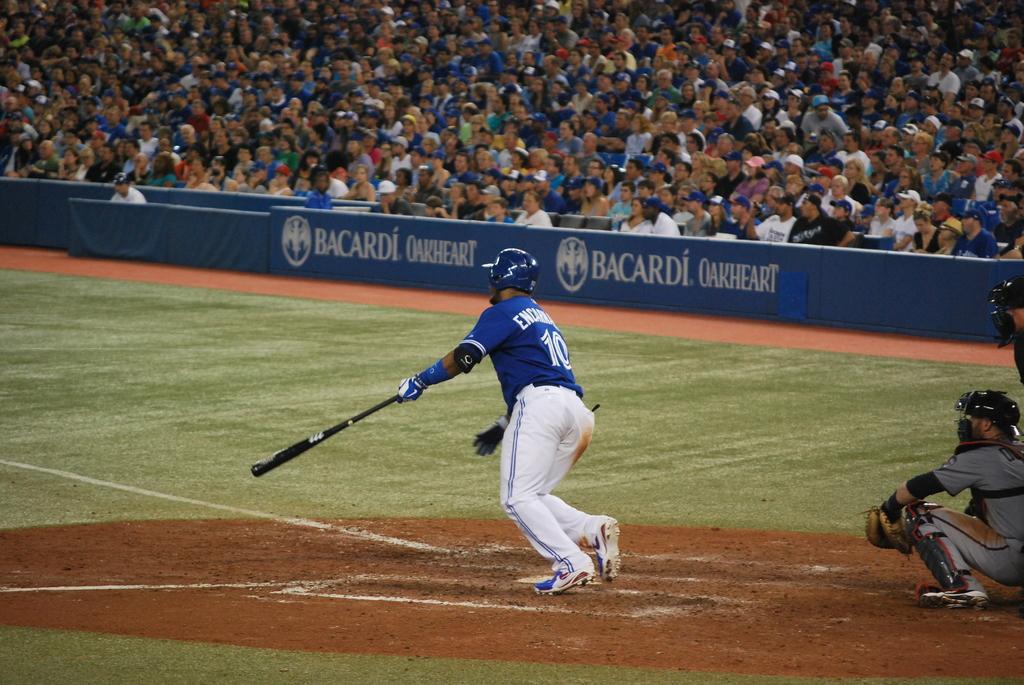What company is advertising at the ball game?
Your answer should be compact. Bacardi. Is bacardi a rum or vodka?
Offer a very short reply. Answering does not require reading text in the image. 